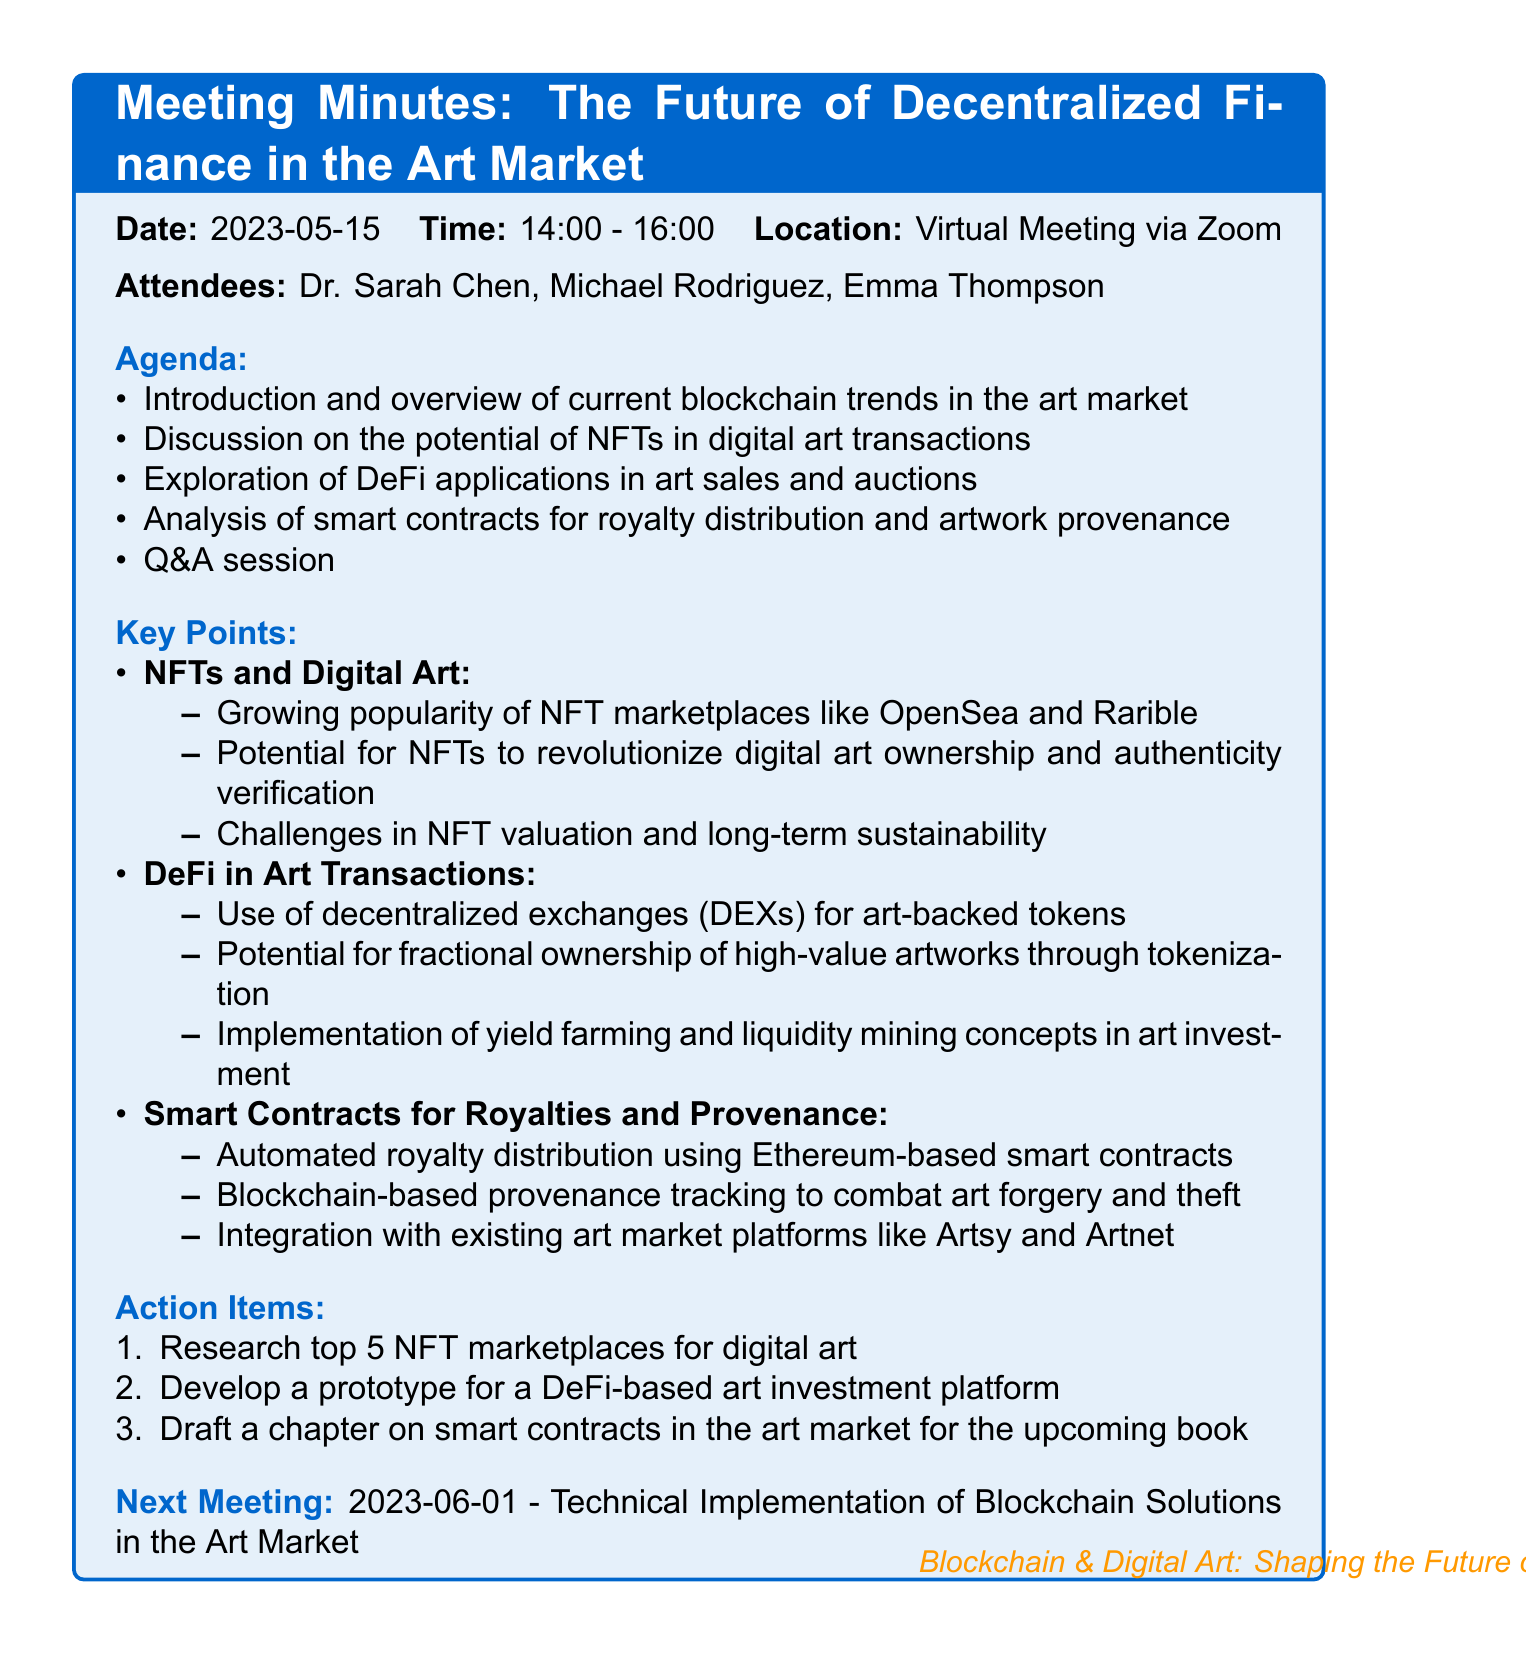What is the meeting title? The meeting title is explicitly stated at the top of the document.
Answer: The Future of Decentralized Finance in the Art Market Who is the cryptocurrency expert present at the meeting? The document lists attendees, specifically naming the cryptocurrency expert.
Answer: Michael Rodriguez What is one of the agenda items for the meeting? The agenda items are listed in bullet points detailing the topics discussed during the meeting.
Answer: Discussion on the potential of NFTs in digital art transactions What date is the next meeting scheduled for? The next meeting date is mentioned towards the end of the document.
Answer: 2023-06-01 What is one of the action items listed from the meeting? The action items are outlined in a numbered list detailing tasks to be completed after the meeting.
Answer: Research top 5 NFT marketplaces for digital art What is a key point discussed concerning smart contracts? Key points are detailed under each topic, summarizing the discussions held during the meeting.
Answer: Automated royalty distribution using Ethereum-based smart contracts What location is indicated for the virtual meeting? The meeting location is specified within the meeting details section.
Answer: Virtual Meeting via Zoom How long did the meeting last? The meeting duration is provided with the start and end time mentioned in the meeting details.
Answer: 2 hours 